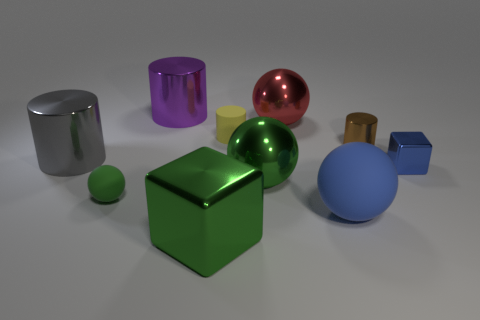How do the sizes of the objects compare to each other? The objects in the image vary in size. The green glossy sphere appears to be the largest object, while the purple cylinder is the tallest when considering height alone. The gold and metallic cylinders are of medium height, and the cubes are relatively smaller compared to the spheres and cylinders. The blue sphere is slightly smaller than the green one, and there are also smaller objects like a yellow cube and a small green sphere that are diminutive in comparison to the rest. Is there any pattern in the arrangement of the objects? There doesn't seem to be a strict pattern in the arrangement; however, the objects are positioned with a sense of balance and spacing that provides a pleasant composition. Some objects partially overlap in perspective, like the blue sphere behind the green cube, which creates depth in the arrangement. The placement seems deliberate to showcase the differences in color, material, and size. 